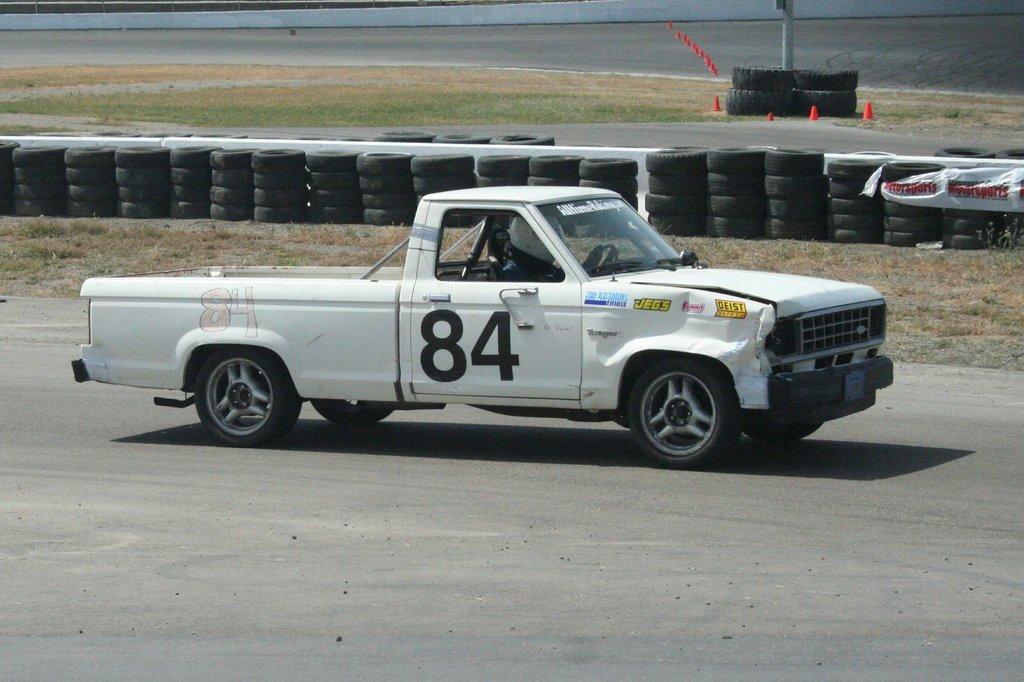In one or two sentences, can you explain what this image depicts? In this picture there is a vehicle on the road and there is a person sitting inside the vehicle and there is a text on the vehicle. At the back there are tiers and there is a pole. At the bottom there is a road and there is grass. 